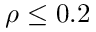Convert formula to latex. <formula><loc_0><loc_0><loc_500><loc_500>\rho \leq 0 . 2</formula> 